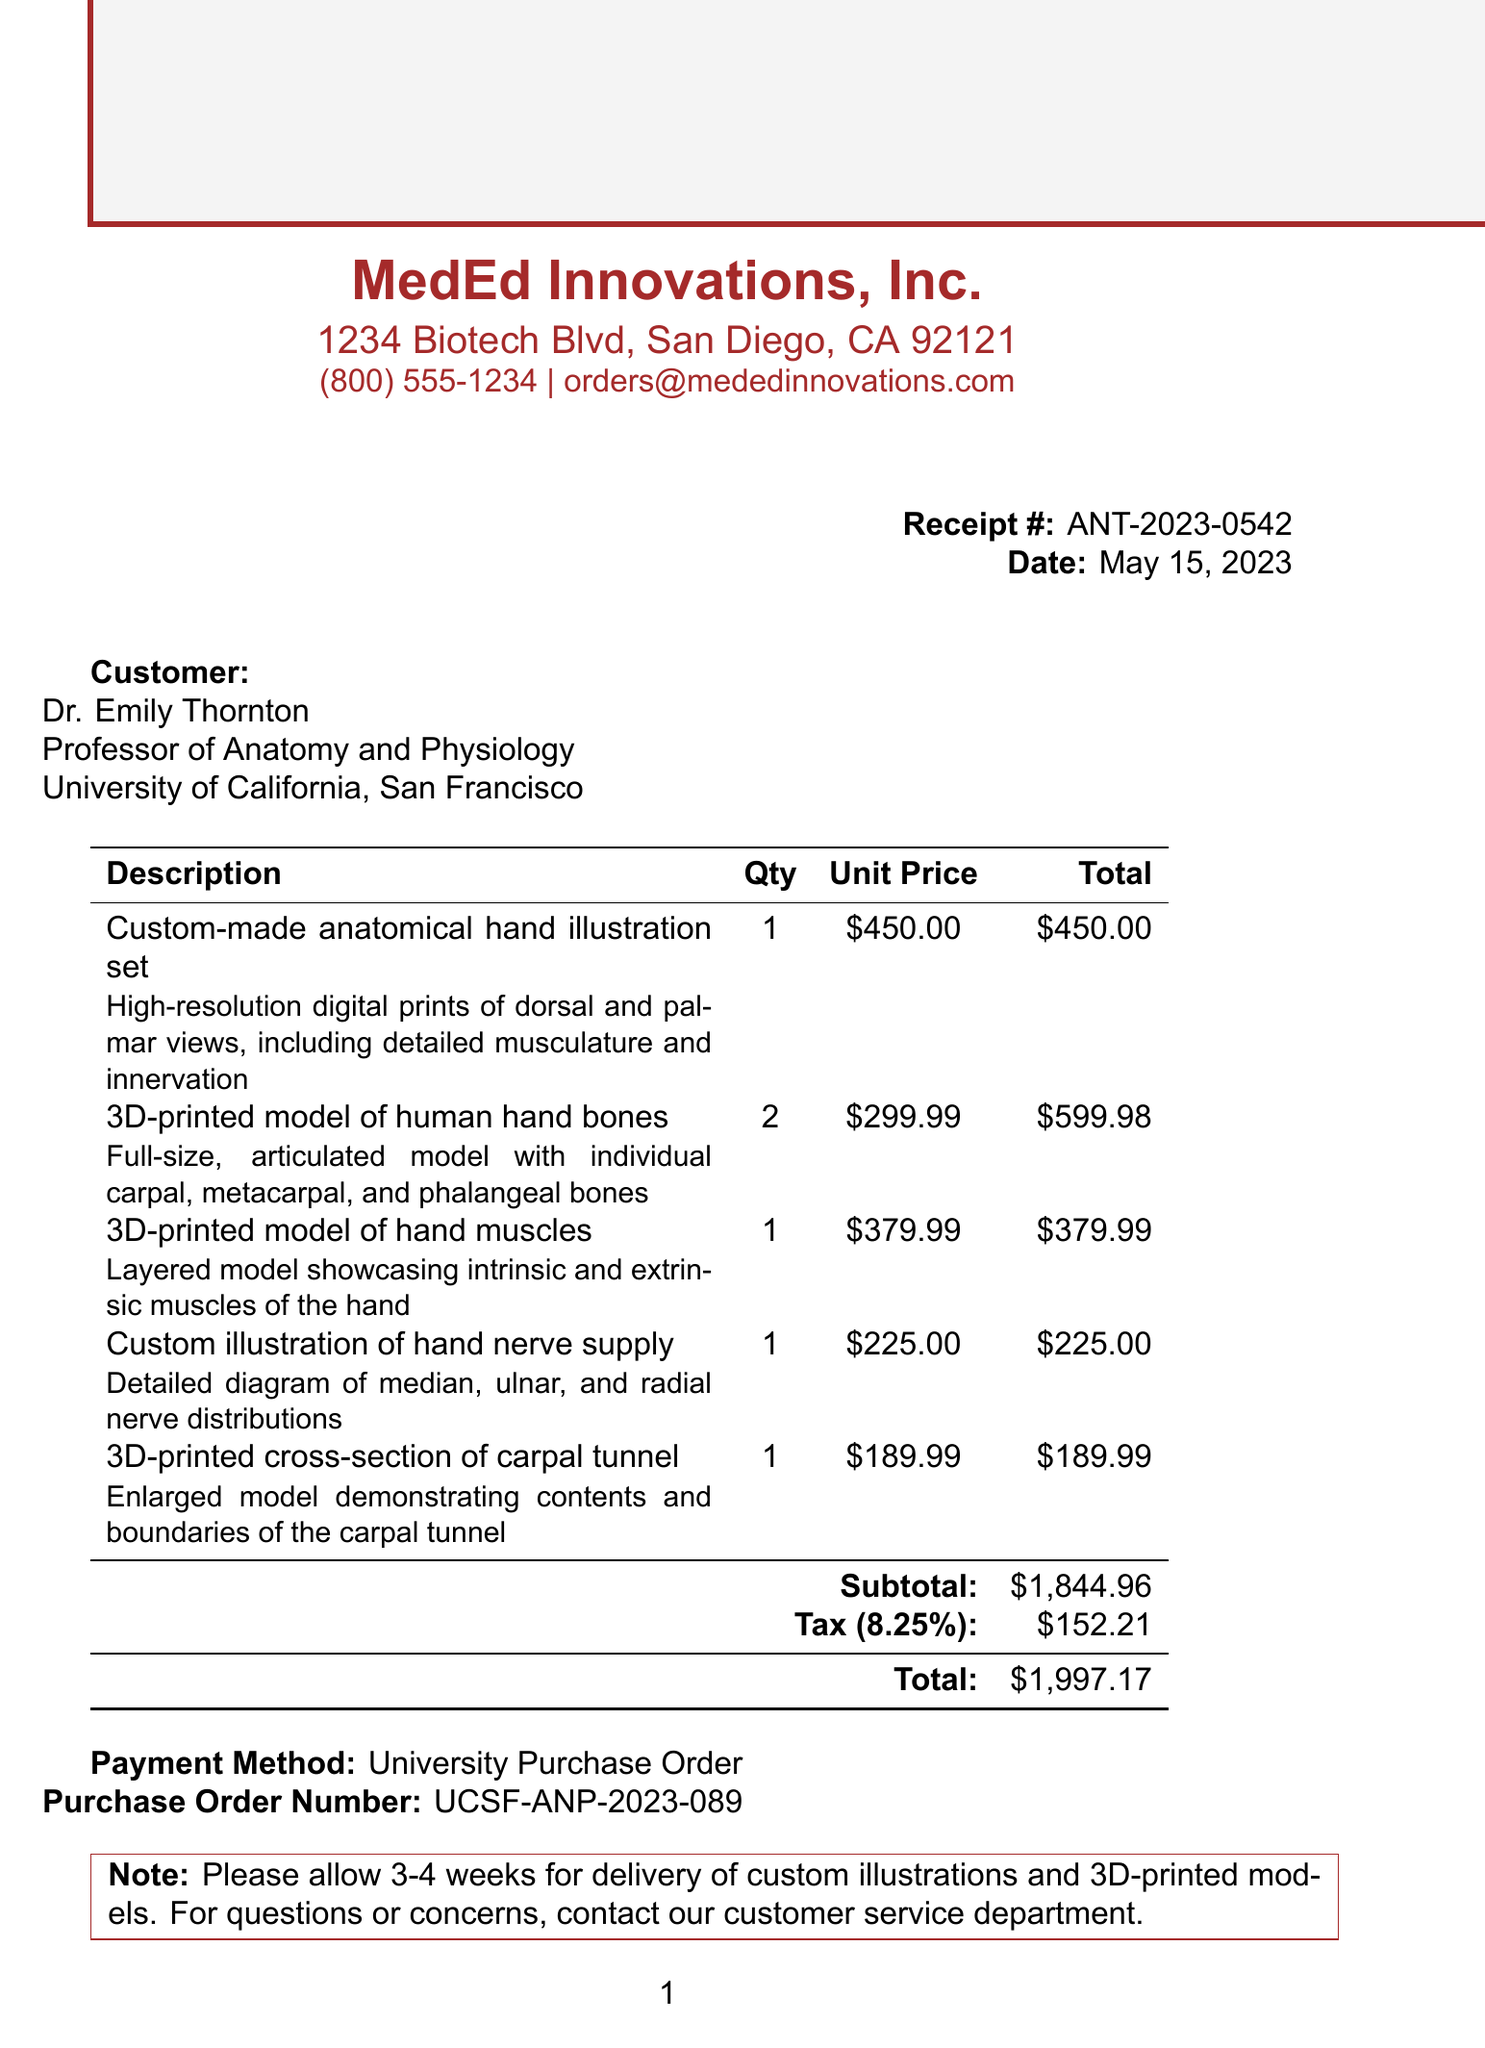What is the receipt number? The receipt number is a unique identifier for the transaction listed in the document.
Answer: ANT-2023-0542 What is the total amount due? The total amount due is the final figure that includes the subtotal and tax.
Answer: $1997.17 Who is the customer? The customer details include their name, title, and the institution they represent.
Answer: Dr. Emily Thornton What date was the receipt issued? The date indicates when the transaction was completed as per the receipt.
Answer: May 15, 2023 What payment method was used? The payment method is how the transaction was processed, specified in the document.
Answer: University Purchase Order How many 3D-printed models of hand bones were ordered? This reflects the quantity of a specific item listed on the receipt.
Answer: 2 What is the subtotal amount? The subtotal represents the total cost of items before tax is added.
Answer: $1,844.96 What is the tax rate applied? The tax rate specifies the percentage charged for tax based on the subtotal.
Answer: 8.25% What items are included in the order? This question asks for a summary of all the products purchased as listed in the document.
Answer: Custom-made anatomical hand illustration set, 3D-printed model of human hand bones, 3D-printed model of hand muscles, custom illustration of hand nerve supply, 3D-printed cross-section of carpal tunnel 